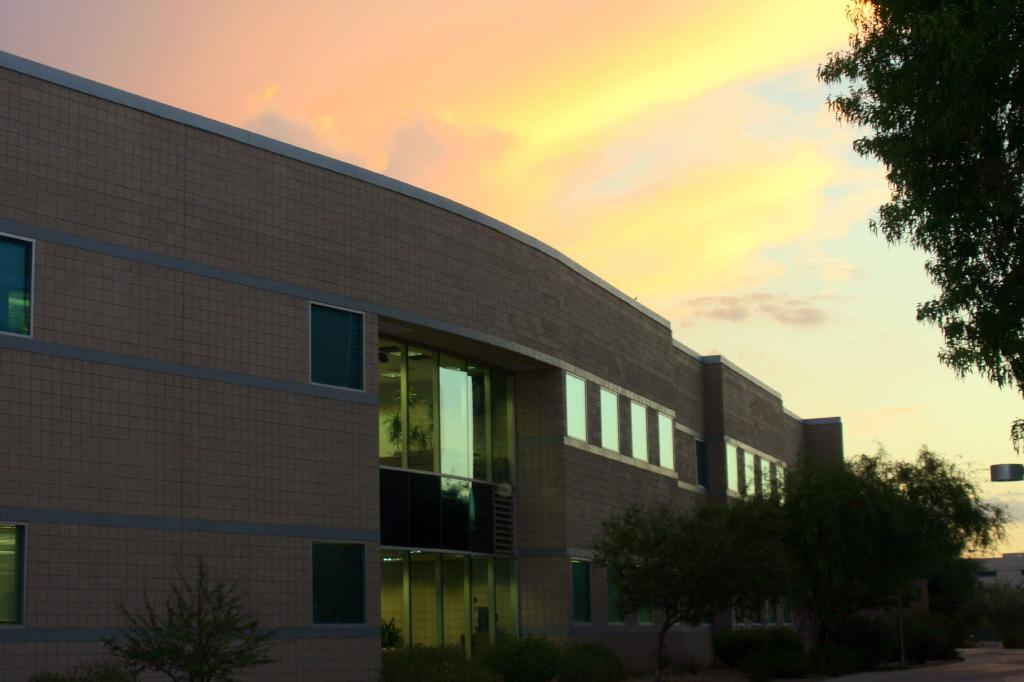What type of vegetation can be seen in the image? There are plants and trees in the image. Are there any structures visible in the image? Yes, there is a building in the image. What can be seen in the background of the image? The sky is visible in the background of the image. How many cows can be seen grazing in the image? There are no cows present in the image; it features plants, trees, a building, and the sky. What type of bird is perched on the tree in the image? There is no bird visible in the image; it only shows plants, trees, a building, and the sky. 